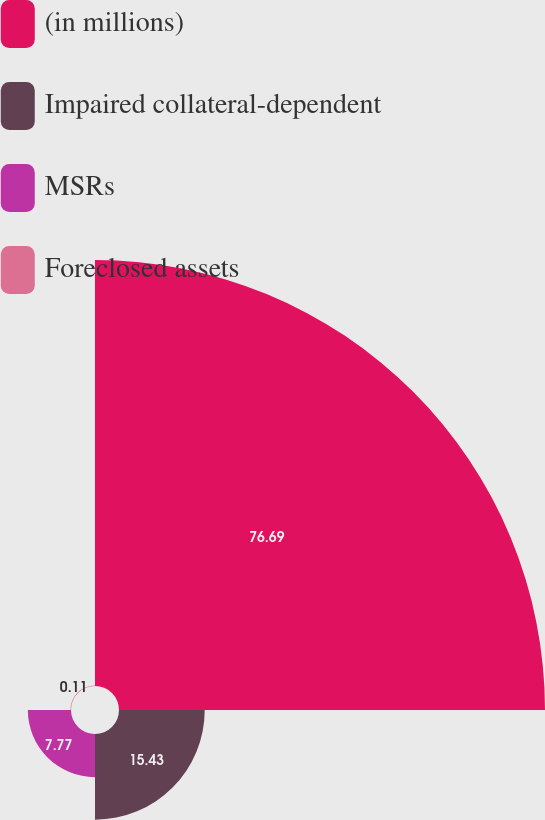Convert chart. <chart><loc_0><loc_0><loc_500><loc_500><pie_chart><fcel>(in millions)<fcel>Impaired collateral-dependent<fcel>MSRs<fcel>Foreclosed assets<nl><fcel>76.69%<fcel>15.43%<fcel>7.77%<fcel>0.11%<nl></chart> 